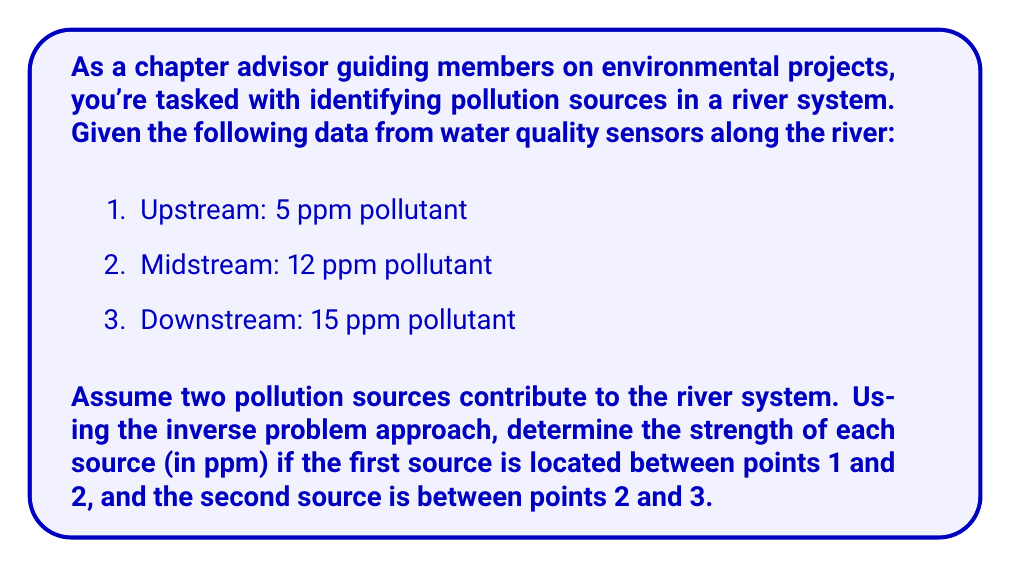Can you solve this math problem? Let's approach this step-by-step:

1) Let $x_1$ be the strength of the first source and $x_2$ be the strength of the second source.

2) We can set up a system of equations based on the given information:

   $$\begin{cases}
   5 + x_1 = 12 \\
   12 + x_2 = 15
   \end{cases}$$

3) From the first equation:
   $$x_1 = 12 - 5 = 7 \text{ ppm}$$

4) From the second equation:
   $$x_2 = 15 - 12 = 3 \text{ ppm}$$

5) We can verify our solution:
   - Upstream to midstream: $5 + 7 = 12$ ppm (matches given data)
   - Midstream to downstream: $12 + 3 = 15$ ppm (matches given data)

Therefore, the strength of the first source is 7 ppm, and the strength of the second source is 3 ppm.
Answer: First source: 7 ppm, Second source: 3 ppm 